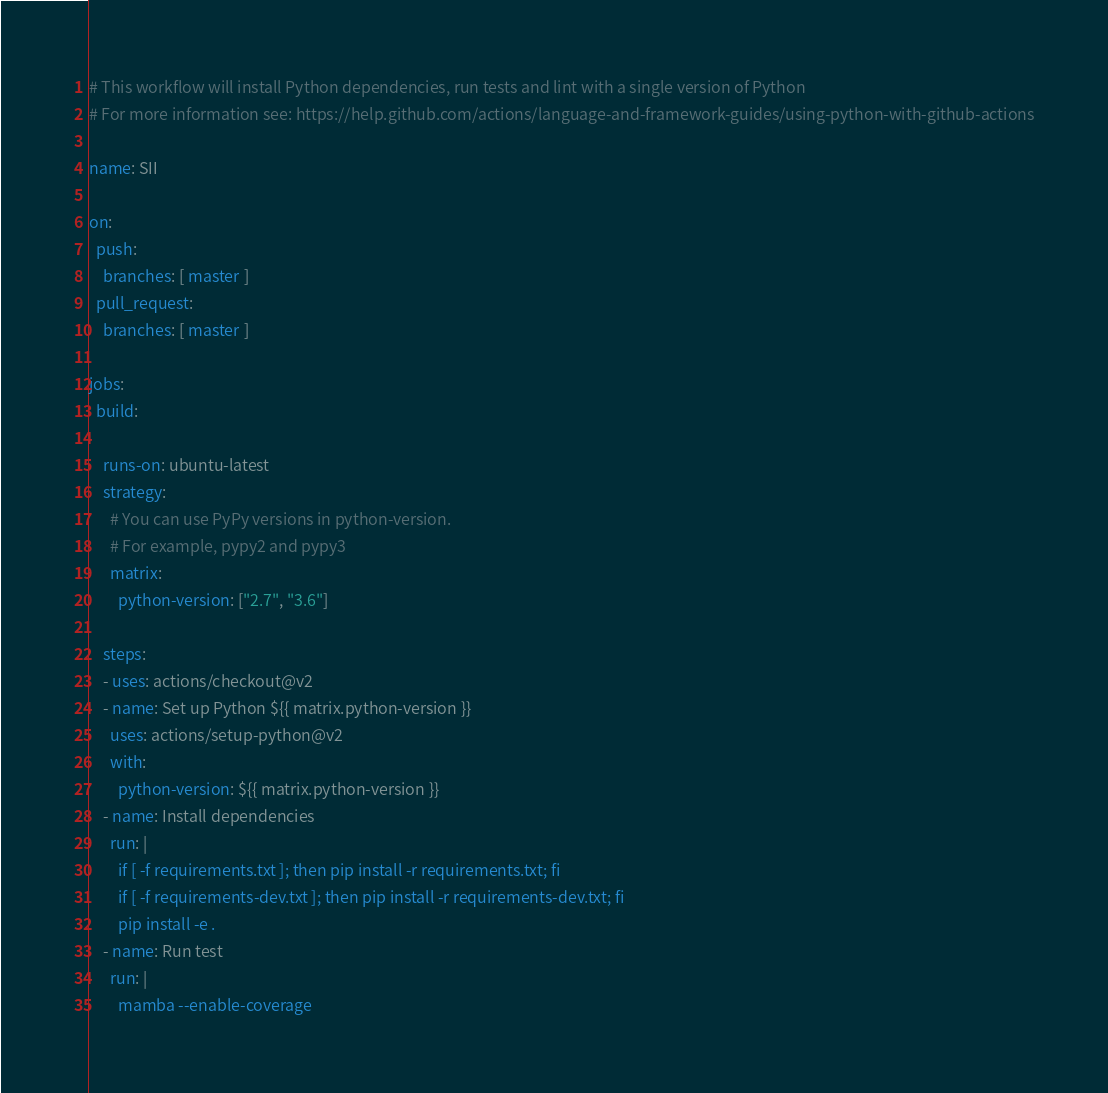Convert code to text. <code><loc_0><loc_0><loc_500><loc_500><_YAML_># This workflow will install Python dependencies, run tests and lint with a single version of Python
# For more information see: https://help.github.com/actions/language-and-framework-guides/using-python-with-github-actions

name: SII

on:
  push:
    branches: [ master ]
  pull_request:
    branches: [ master ]

jobs:
  build:

    runs-on: ubuntu-latest
    strategy:
      # You can use PyPy versions in python-version.
      # For example, pypy2 and pypy3
      matrix:
        python-version: ["2.7", "3.6"]

    steps:
    - uses: actions/checkout@v2
    - name: Set up Python ${{ matrix.python-version }}
      uses: actions/setup-python@v2
      with:
        python-version: ${{ matrix.python-version }}
    - name: Install dependencies
      run: |
        if [ -f requirements.txt ]; then pip install -r requirements.txt; fi
        if [ -f requirements-dev.txt ]; then pip install -r requirements-dev.txt; fi
        pip install -e .
    - name: Run test
      run: |
        mamba --enable-coverage
</code> 